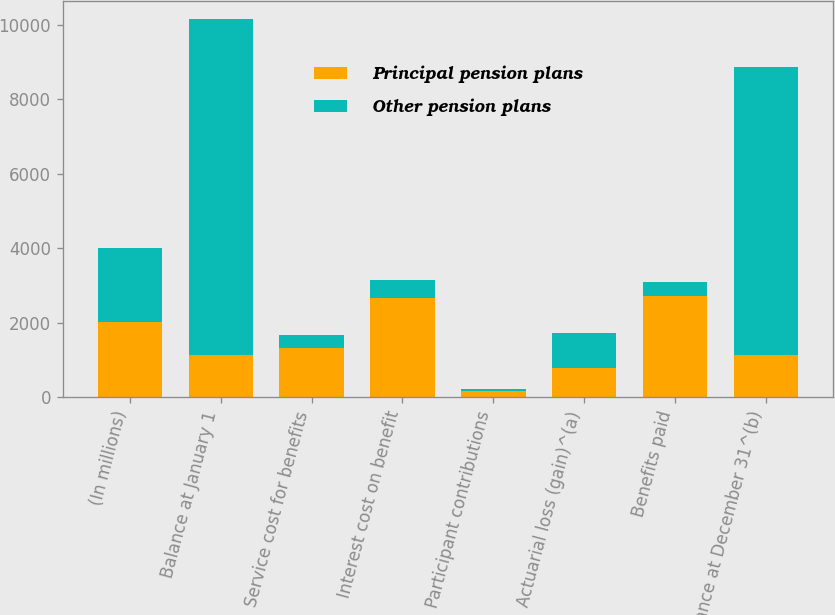Convert chart. <chart><loc_0><loc_0><loc_500><loc_500><stacked_bar_chart><ecel><fcel>(In millions)<fcel>Balance at January 1<fcel>Service cost for benefits<fcel>Interest cost on benefit<fcel>Participant contributions<fcel>Actuarial loss (gain)^(a)<fcel>Benefits paid<fcel>Balance at December 31^(b)<nl><fcel>Principal pension plans<fcel>2008<fcel>1127<fcel>1331<fcel>2653<fcel>169<fcel>791<fcel>2723<fcel>1127<nl><fcel>Other pension plans<fcel>2008<fcel>9014<fcel>332<fcel>499<fcel>40<fcel>923<fcel>383<fcel>7748<nl></chart> 